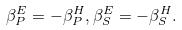Convert formula to latex. <formula><loc_0><loc_0><loc_500><loc_500>\beta _ { P } ^ { E } = - \beta _ { P } ^ { H } , \beta _ { S } ^ { E } = - \beta _ { S } ^ { H } .</formula> 